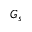Convert formula to latex. <formula><loc_0><loc_0><loc_500><loc_500>G _ { s }</formula> 